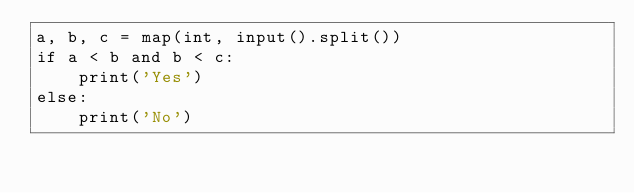<code> <loc_0><loc_0><loc_500><loc_500><_Python_>a, b, c = map(int, input().split())
if a < b and b < c:
    print('Yes')
else:
    print('No')

</code> 